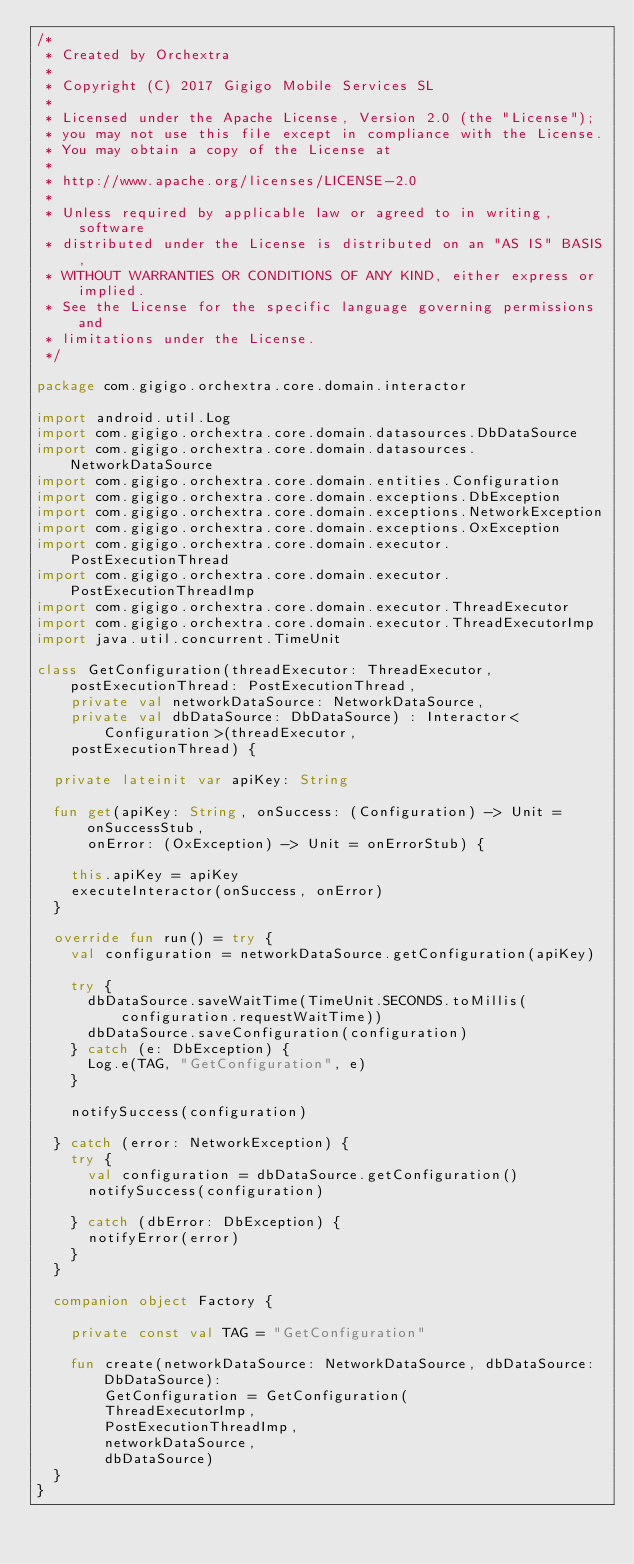<code> <loc_0><loc_0><loc_500><loc_500><_Kotlin_>/*
 * Created by Orchextra
 *
 * Copyright (C) 2017 Gigigo Mobile Services SL
 *
 * Licensed under the Apache License, Version 2.0 (the "License");
 * you may not use this file except in compliance with the License.
 * You may obtain a copy of the License at
 *
 * http://www.apache.org/licenses/LICENSE-2.0
 *
 * Unless required by applicable law or agreed to in writing, software
 * distributed under the License is distributed on an "AS IS" BASIS,
 * WITHOUT WARRANTIES OR CONDITIONS OF ANY KIND, either express or implied.
 * See the License for the specific language governing permissions and
 * limitations under the License.
 */

package com.gigigo.orchextra.core.domain.interactor

import android.util.Log
import com.gigigo.orchextra.core.domain.datasources.DbDataSource
import com.gigigo.orchextra.core.domain.datasources.NetworkDataSource
import com.gigigo.orchextra.core.domain.entities.Configuration
import com.gigigo.orchextra.core.domain.exceptions.DbException
import com.gigigo.orchextra.core.domain.exceptions.NetworkException
import com.gigigo.orchextra.core.domain.exceptions.OxException
import com.gigigo.orchextra.core.domain.executor.PostExecutionThread
import com.gigigo.orchextra.core.domain.executor.PostExecutionThreadImp
import com.gigigo.orchextra.core.domain.executor.ThreadExecutor
import com.gigigo.orchextra.core.domain.executor.ThreadExecutorImp
import java.util.concurrent.TimeUnit

class GetConfiguration(threadExecutor: ThreadExecutor, postExecutionThread: PostExecutionThread,
    private val networkDataSource: NetworkDataSource,
    private val dbDataSource: DbDataSource) : Interactor<Configuration>(threadExecutor,
    postExecutionThread) {

  private lateinit var apiKey: String

  fun get(apiKey: String, onSuccess: (Configuration) -> Unit = onSuccessStub,
      onError: (OxException) -> Unit = onErrorStub) {

    this.apiKey = apiKey
    executeInteractor(onSuccess, onError)
  }

  override fun run() = try {
    val configuration = networkDataSource.getConfiguration(apiKey)

    try {
      dbDataSource.saveWaitTime(TimeUnit.SECONDS.toMillis(configuration.requestWaitTime))
      dbDataSource.saveConfiguration(configuration)
    } catch (e: DbException) {
      Log.e(TAG, "GetConfiguration", e)
    }

    notifySuccess(configuration)

  } catch (error: NetworkException) {
    try {
      val configuration = dbDataSource.getConfiguration()
      notifySuccess(configuration)

    } catch (dbError: DbException) {
      notifyError(error)
    }
  }

  companion object Factory {

    private const val TAG = "GetConfiguration"

    fun create(networkDataSource: NetworkDataSource, dbDataSource: DbDataSource):
        GetConfiguration = GetConfiguration(
        ThreadExecutorImp,
        PostExecutionThreadImp,
        networkDataSource,
        dbDataSource)
  }
}</code> 